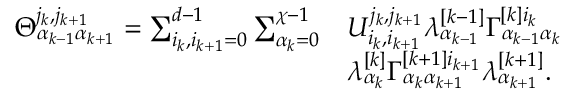Convert formula to latex. <formula><loc_0><loc_0><loc_500><loc_500>\begin{array} { r l } { \Theta _ { \alpha _ { k - 1 } \alpha _ { k + 1 } } ^ { j _ { k } , j _ { k + 1 } } = \sum _ { i _ { k } , i _ { k + 1 } = 0 } ^ { d - 1 } \sum _ { \alpha _ { k } = 0 } ^ { \chi - 1 } } & { U _ { i _ { k } , i _ { k + 1 } } ^ { j _ { k } , j _ { k + 1 } } \lambda _ { \alpha _ { k - 1 } } ^ { [ k - 1 ] } \Gamma _ { \alpha _ { k - 1 } \alpha _ { k } } ^ { [ k ] i _ { k } } } \\ & { \lambda _ { \alpha _ { k } } ^ { [ k ] } \Gamma _ { \alpha _ { k } \alpha _ { k + 1 } } ^ { [ k + 1 ] i _ { k + 1 } } \lambda _ { \alpha _ { k + 1 } } ^ { [ k + 1 ] } . } \end{array}</formula> 